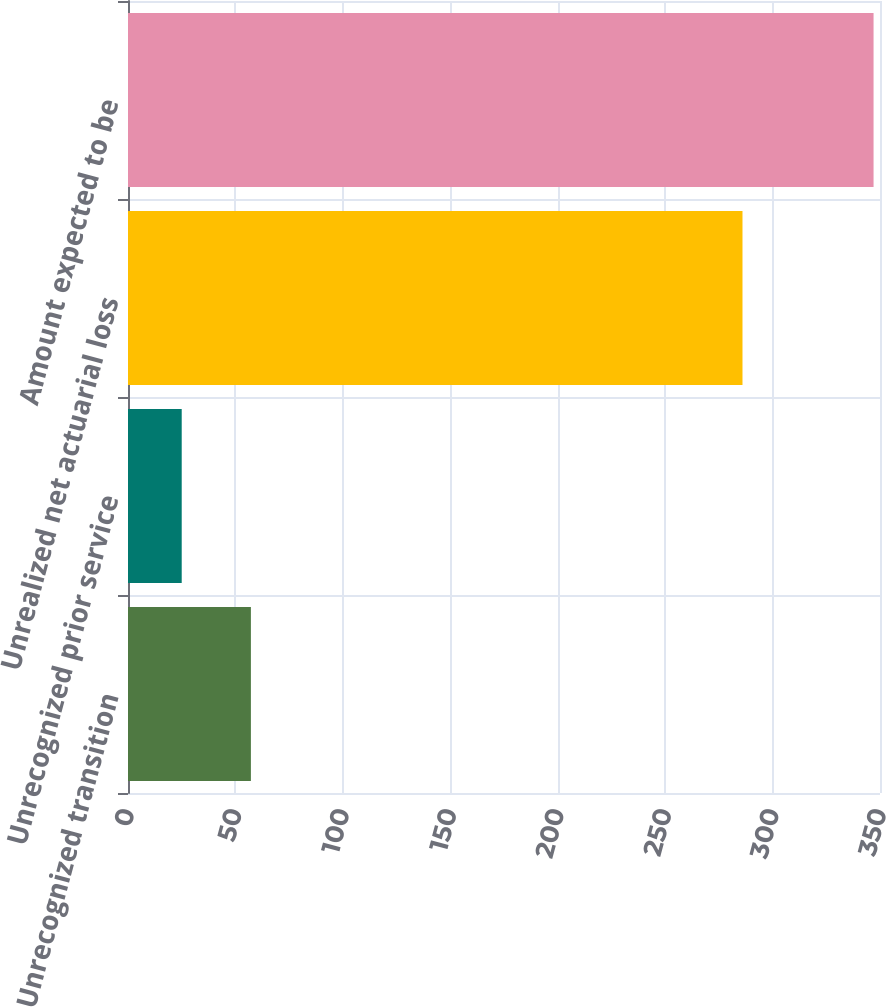Convert chart. <chart><loc_0><loc_0><loc_500><loc_500><bar_chart><fcel>Unrecognized transition<fcel>Unrecognized prior service<fcel>Unrealized net actuarial loss<fcel>Amount expected to be<nl><fcel>57.2<fcel>25<fcel>286<fcel>347<nl></chart> 